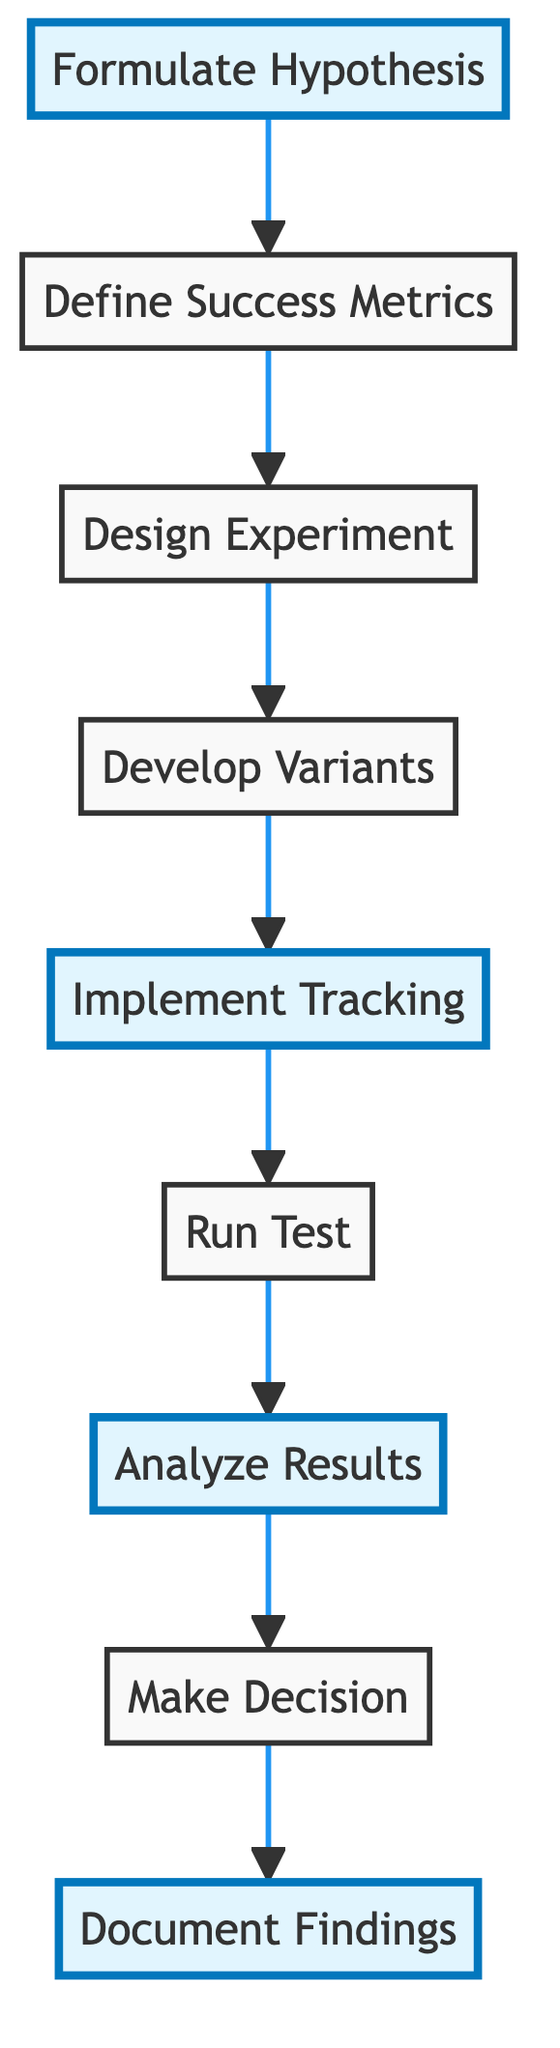What is the first step in the A/B testing procedure? The first step is "Formulate Hypothesis," as indicated by the starting node in the flow chart.
Answer: Formulate Hypothesis How many steps are there in the diagram? The diagram consists of a total of nine steps, as there are nine nodes sequentially linked.
Answer: Nine What step comes after "Implement Tracking"? The next step after "Implement Tracking" is "Run Test," which is the step that follows it in the flow of the diagram.
Answer: Run Test Which step focuses on recording the results? The last step in the flowchart is "Document Findings," which specifically addresses the recording of the results.
Answer: Document Findings Which steps are highlighted in the diagram? The highlighted steps are "Formulate Hypothesis," "Implement Tracking," "Analyze Results," and "Document Findings," indicated by a distinct style in the flow chart.
Answer: Formulate Hypothesis, Implement Tracking, Analyze Results, Document Findings What is the purpose of "Define Success Metrics"? The purpose of "Define Success Metrics" is to identify key performance indicators (KPIs) used to measure the success of the A/B test, as described in the flow chart.
Answer: Identify key performance indicators What is implied by "Make Decision" in the diagram? "Make Decision" implies evaluating the results of the A/B test to implement the new design element based on analytical findings.
Answer: Evaluate results to implement design Which two steps directly precede "Analyze Results"? The steps that directly precede "Analyze Results" are "Run Test" and "Implement Tracking," forming the sequence leading to the analysis.
Answer: Run Test, Implement Tracking In what context is “Develop Variants” used in the procedure? "Develop Variants" refers to the creation of design elements for both control and variant groups in the A/B testing procedure.
Answer: Create design elements for control and variant groups 